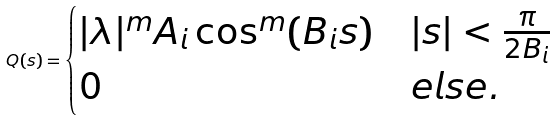Convert formula to latex. <formula><loc_0><loc_0><loc_500><loc_500>Q ( s ) = \begin{cases} | \lambda | ^ { m } A _ { i } \cos ^ { m } ( B _ { i } s ) & | s | < \frac { \pi } { 2 B _ { i } } \\ 0 & e l s e . \end{cases}</formula> 